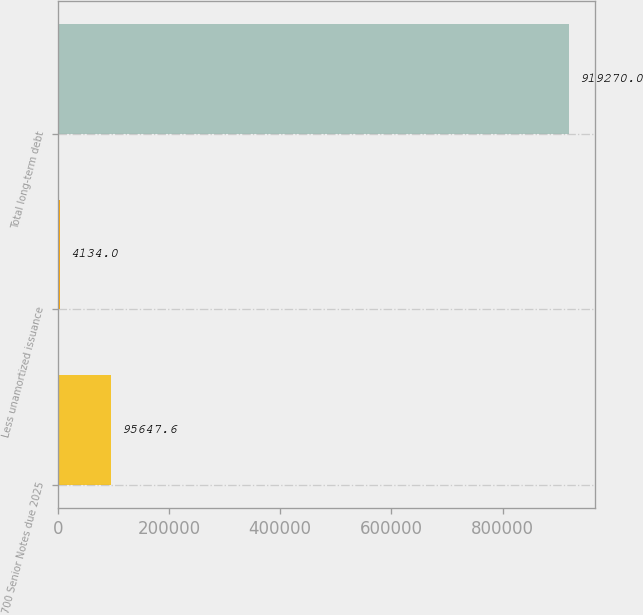<chart> <loc_0><loc_0><loc_500><loc_500><bar_chart><fcel>700 Senior Notes due 2025<fcel>Less unamortized issuance<fcel>Total long-term debt<nl><fcel>95647.6<fcel>4134<fcel>919270<nl></chart> 